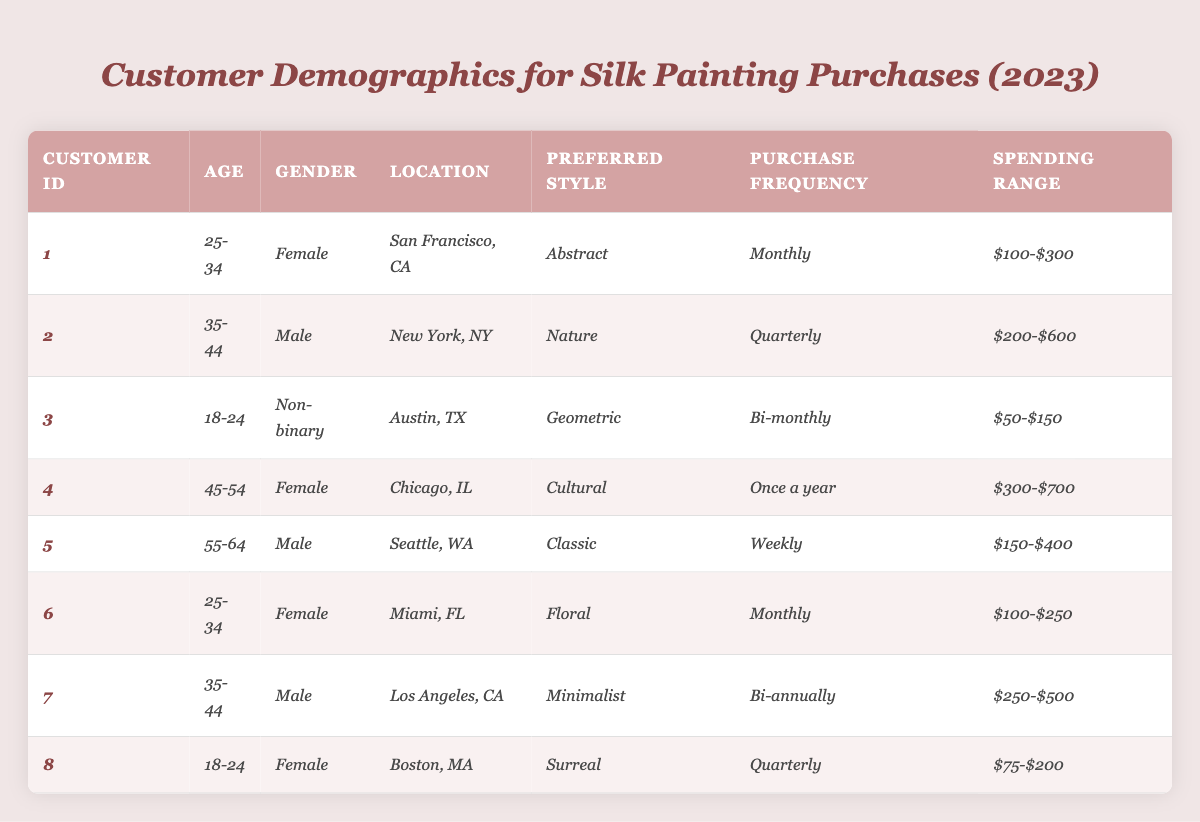What is the most common purchase frequency among the customers? By examining the "Purchase Frequency" column, we see that "Monthly" is mentioned for CustomerID 1 and 6 (2 occurrences), while "Quarterly" for 2 and 8 (2 occurrences), "Bi-monthly" for 3 (1 occurrence), "Once a year" for 4 (1 occurrence), "Weekly" for 5 (1 occurrence), and "Bi-annually" for 7 (1 occurrence). Therefore, the purchase frequencies that occur most often are "Monthly" and "Quarterly."
Answer: Monthly and Quarterly Which customer has the highest spending range? The spending ranges are $100-$300, $200-$600, $50-$150, $300-$700, $150-$400, $100-$250, $250-$500, and $75-$200. The maximum value is identified in the range $300-$700 for CustomerID 4.
Answer: CustomerID 4 Is there a customer who prefers a floral style? Looking at the "Preferred Style" column, we find that CustomerID 6 has "Floral" as their preferred style, confirming that at least one customer prefers this style.
Answer: Yes What is the average age group of customers who purchase silk paintings? The age groups are 18-24, 25-34, 35-44, 45-54, and 55-64. To find the average, we can categorize them by their midpoint: 21 (18-24), 29.5 (25-34), 39.5 (35-44), 49.5 (45-54), and 59.5 (55-64). The total occurrences are 8, and summing up the midpoints and dividing gives us an average age of 39.5.
Answer: 39.5 How many male customers have a bi-annual or quarterly purchase frequency? Checking the "Purchase Frequency" column, two males (CustomerID 2 and 7) have "Quarterly" (1 occurrence) and "Bi-annually" (1 occurrence) respectively. Therefore, there are 2 male customers meeting this condition.
Answer: 2 Which location has the highest representation among the customer demographics? The locations listed are San Francisco, New York, Austin, Chicago, Seattle, Miami, and Los Angeles. Each one appears once, except Miami has two entries which contribute to a higher count and thereby the highest representation is in Miami.
Answer: Miami What is the preferred style of the youngest customer in the table? The youngest customer is identified as CustomerID 3 with an age group of 18-24. Their preferred style is "Geometric." Hence, the preferred style of the youngest customer is geometric.
Answer: Geometric Count how many unique preferred styles are there among all customers? The unique styles presented are Abstract, Nature, Geometric, Cultural, Classic, Floral, Minimalist, and Surreal, totaling to 8 different styles.
Answer: 8 